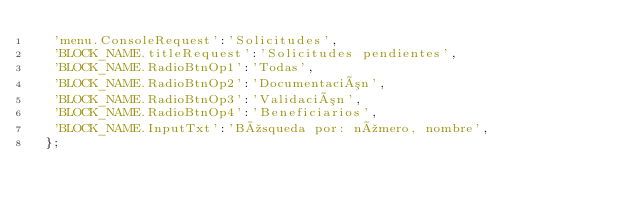Convert code to text. <code><loc_0><loc_0><loc_500><loc_500><_TypeScript_>  'menu.ConsoleRequest':'Solicitudes',
  'BLOCK_NAME.titleRequest':'Solicitudes pendientes',
  'BLOCK_NAME.RadioBtnOp1':'Todas',
  'BLOCK_NAME.RadioBtnOp2':'Documentación',
  'BLOCK_NAME.RadioBtnOp3':'Validación',
  'BLOCK_NAME.RadioBtnOp4':'Beneficiarios',
  'BLOCK_NAME.InputTxt':'Búsqueda por: número, nombre',  
 };</code> 